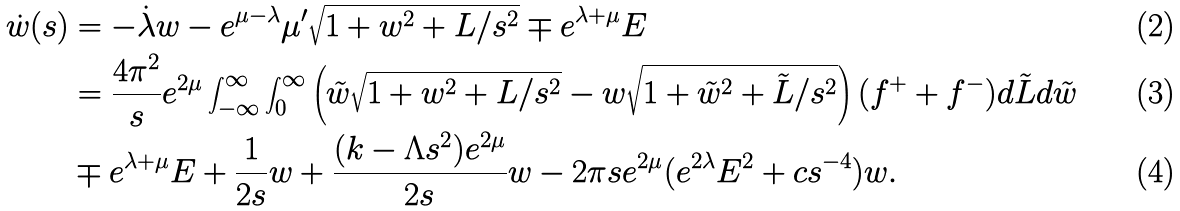<formula> <loc_0><loc_0><loc_500><loc_500>\dot { w } ( s ) & = - \dot { \lambda } w - e ^ { \mu - \lambda } \mu ^ { \prime } \sqrt { 1 + w ^ { 2 } + L / s ^ { 2 } } \mp e ^ { \lambda + \mu } E \\ & = \frac { 4 \pi ^ { 2 } } { s } e ^ { 2 \mu } \int _ { - \infty } ^ { \infty } \int _ { 0 } ^ { \infty } \left ( \tilde { w } \sqrt { 1 + w ^ { 2 } + L / s ^ { 2 } } - w \sqrt { 1 + \tilde { w } ^ { 2 } + \tilde { L } / s ^ { 2 } } \right ) ( f ^ { + } + f ^ { - } ) d \tilde { L } d \tilde { w } \\ & \mp e ^ { \lambda + \mu } E + \frac { 1 } { 2 s } w + \frac { ( k - \Lambda s ^ { 2 } ) e ^ { 2 \mu } } { 2 s } w - 2 \pi s e ^ { 2 \mu } ( e ^ { 2 \lambda } E ^ { 2 } + c s ^ { - 4 } ) w .</formula> 